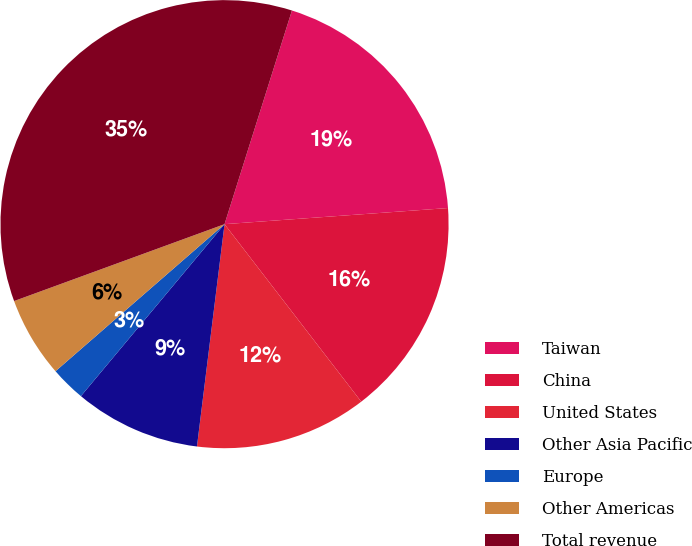Convert chart to OTSL. <chart><loc_0><loc_0><loc_500><loc_500><pie_chart><fcel>Taiwan<fcel>China<fcel>United States<fcel>Other Asia Pacific<fcel>Europe<fcel>Other Americas<fcel>Total revenue<nl><fcel>18.99%<fcel>15.7%<fcel>12.41%<fcel>9.11%<fcel>2.53%<fcel>5.82%<fcel>35.44%<nl></chart> 